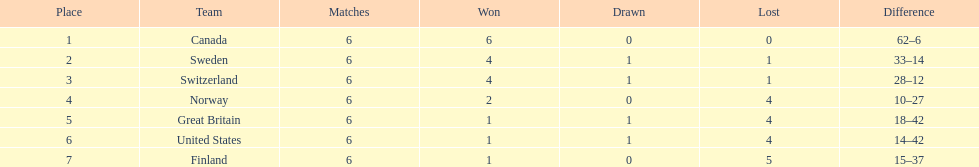Which country performed better during the 1951 world ice hockey championships, switzerland or great britain? Switzerland. 